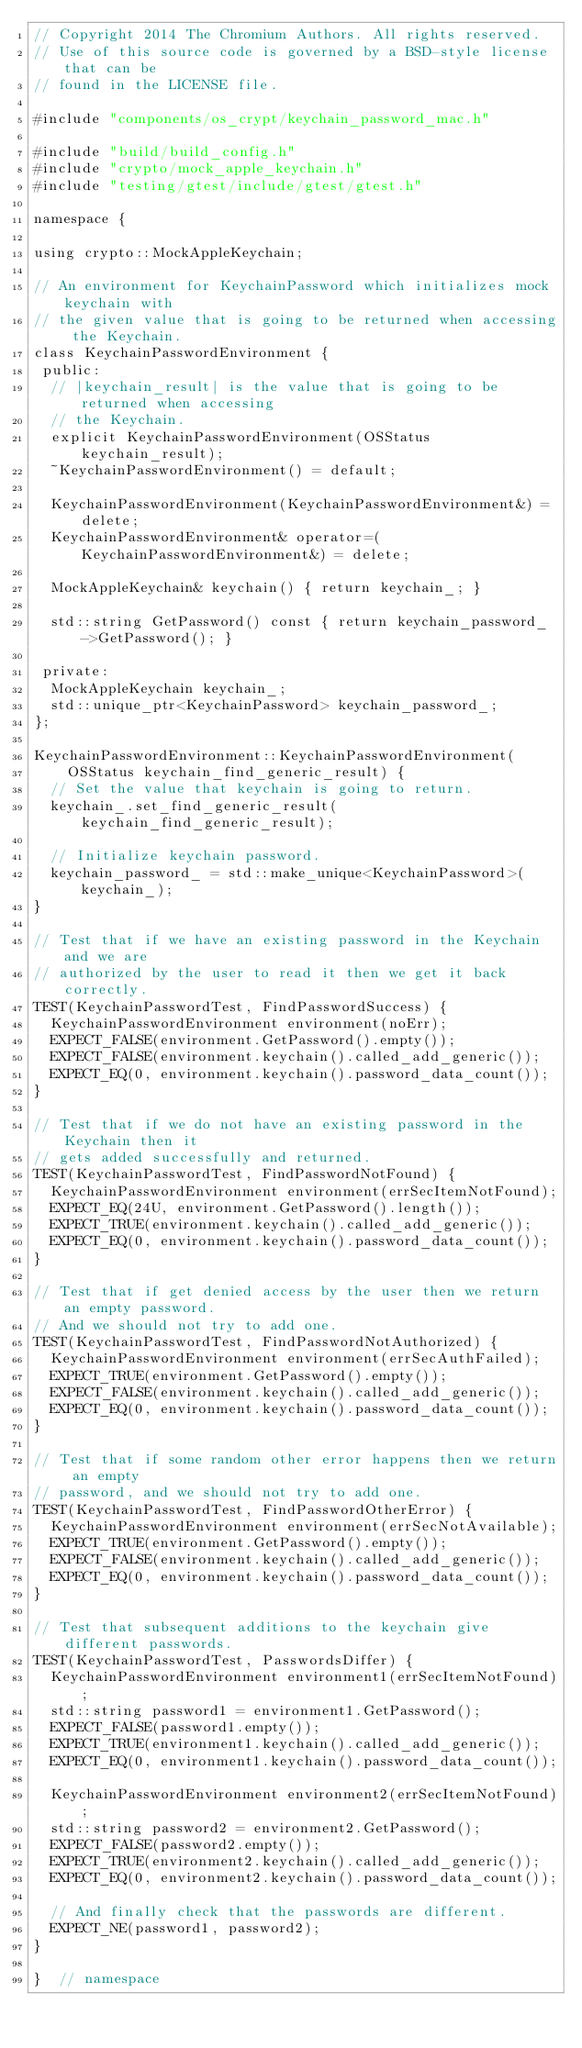<code> <loc_0><loc_0><loc_500><loc_500><_ObjectiveC_>// Copyright 2014 The Chromium Authors. All rights reserved.
// Use of this source code is governed by a BSD-style license that can be
// found in the LICENSE file.

#include "components/os_crypt/keychain_password_mac.h"

#include "build/build_config.h"
#include "crypto/mock_apple_keychain.h"
#include "testing/gtest/include/gtest/gtest.h"

namespace {

using crypto::MockAppleKeychain;

// An environment for KeychainPassword which initializes mock keychain with
// the given value that is going to be returned when accessing the Keychain.
class KeychainPasswordEnvironment {
 public:
  // |keychain_result| is the value that is going to be returned when accessing
  // the Keychain.
  explicit KeychainPasswordEnvironment(OSStatus keychain_result);
  ~KeychainPasswordEnvironment() = default;

  KeychainPasswordEnvironment(KeychainPasswordEnvironment&) = delete;
  KeychainPasswordEnvironment& operator=(KeychainPasswordEnvironment&) = delete;

  MockAppleKeychain& keychain() { return keychain_; }

  std::string GetPassword() const { return keychain_password_->GetPassword(); }

 private:
  MockAppleKeychain keychain_;
  std::unique_ptr<KeychainPassword> keychain_password_;
};

KeychainPasswordEnvironment::KeychainPasswordEnvironment(
    OSStatus keychain_find_generic_result) {
  // Set the value that keychain is going to return.
  keychain_.set_find_generic_result(keychain_find_generic_result);

  // Initialize keychain password.
  keychain_password_ = std::make_unique<KeychainPassword>(keychain_);
}

// Test that if we have an existing password in the Keychain and we are
// authorized by the user to read it then we get it back correctly.
TEST(KeychainPasswordTest, FindPasswordSuccess) {
  KeychainPasswordEnvironment environment(noErr);
  EXPECT_FALSE(environment.GetPassword().empty());
  EXPECT_FALSE(environment.keychain().called_add_generic());
  EXPECT_EQ(0, environment.keychain().password_data_count());
}

// Test that if we do not have an existing password in the Keychain then it
// gets added successfully and returned.
TEST(KeychainPasswordTest, FindPasswordNotFound) {
  KeychainPasswordEnvironment environment(errSecItemNotFound);
  EXPECT_EQ(24U, environment.GetPassword().length());
  EXPECT_TRUE(environment.keychain().called_add_generic());
  EXPECT_EQ(0, environment.keychain().password_data_count());
}

// Test that if get denied access by the user then we return an empty password.
// And we should not try to add one.
TEST(KeychainPasswordTest, FindPasswordNotAuthorized) {
  KeychainPasswordEnvironment environment(errSecAuthFailed);
  EXPECT_TRUE(environment.GetPassword().empty());
  EXPECT_FALSE(environment.keychain().called_add_generic());
  EXPECT_EQ(0, environment.keychain().password_data_count());
}

// Test that if some random other error happens then we return an empty
// password, and we should not try to add one.
TEST(KeychainPasswordTest, FindPasswordOtherError) {
  KeychainPasswordEnvironment environment(errSecNotAvailable);
  EXPECT_TRUE(environment.GetPassword().empty());
  EXPECT_FALSE(environment.keychain().called_add_generic());
  EXPECT_EQ(0, environment.keychain().password_data_count());
}

// Test that subsequent additions to the keychain give different passwords.
TEST(KeychainPasswordTest, PasswordsDiffer) {
  KeychainPasswordEnvironment environment1(errSecItemNotFound);
  std::string password1 = environment1.GetPassword();
  EXPECT_FALSE(password1.empty());
  EXPECT_TRUE(environment1.keychain().called_add_generic());
  EXPECT_EQ(0, environment1.keychain().password_data_count());

  KeychainPasswordEnvironment environment2(errSecItemNotFound);
  std::string password2 = environment2.GetPassword();
  EXPECT_FALSE(password2.empty());
  EXPECT_TRUE(environment2.keychain().called_add_generic());
  EXPECT_EQ(0, environment2.keychain().password_data_count());

  // And finally check that the passwords are different.
  EXPECT_NE(password1, password2);
}

}  // namespace
</code> 